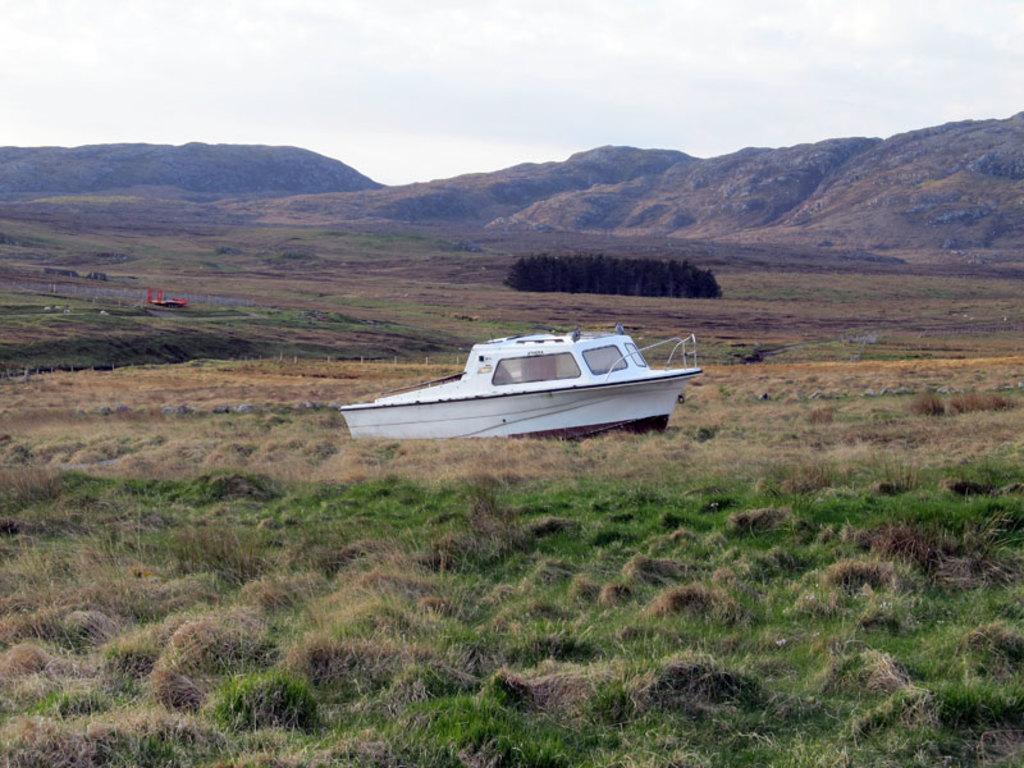How would you summarize this image in a sentence or two? In this picture I can see there is a boat and there's grass on the ground and there are plants. In the backdrop, there are mountains and the sky is clear. 